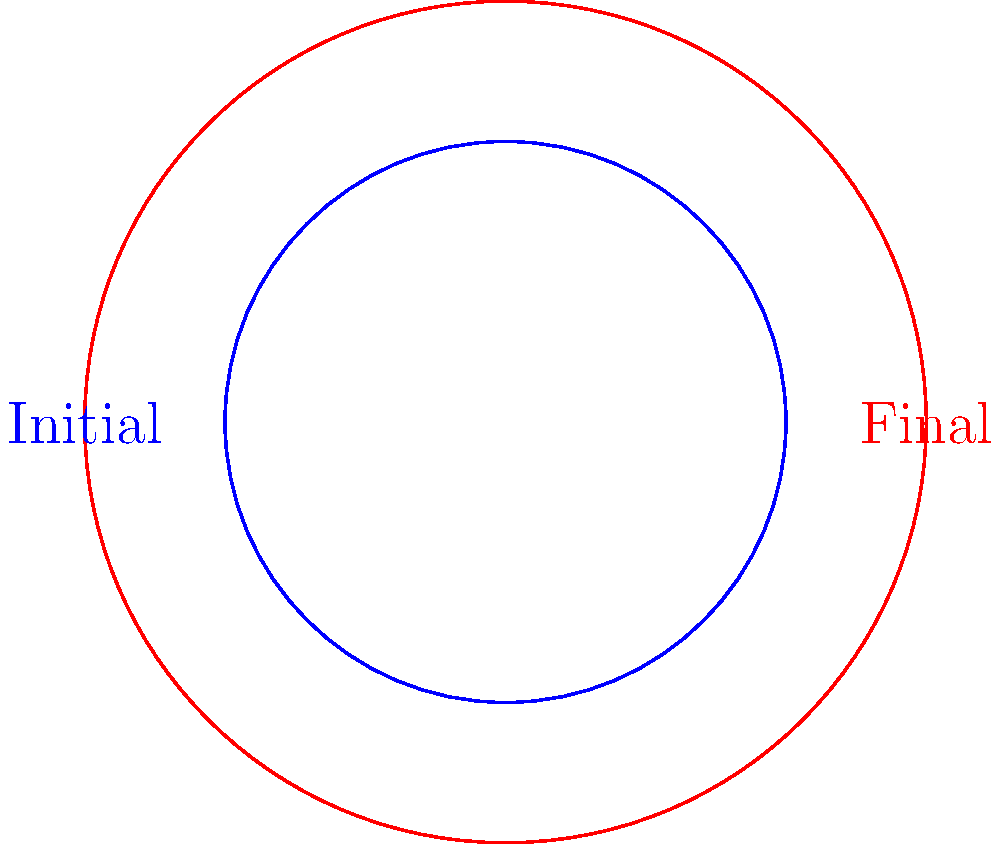As a general practitioner treating patients with addiction, you observe changes in pupil dilation during recovery. The initial pupil area is represented by a circle with radius 1 cm, and after treatment, it increases to a radius of 1.5 cm. Calculate the rate of change in pupil area relative to the change in radius. Express your answer in cm. To solve this problem, we'll follow these steps:

1) The area of a circle is given by the formula $A = \pi r^2$.

2) Let's calculate the initial and final areas:
   Initial area: $A_1 = \pi (1)^2 = \pi$ cm²
   Final area: $A_2 = \pi (1.5)^2 = 2.25\pi$ cm²

3) The change in area is:
   $\Delta A = A_2 - A_1 = 2.25\pi - \pi = 1.25\pi$ cm²

4) The change in radius is:
   $\Delta r = 1.5 - 1 = 0.5$ cm

5) The rate of change in area with respect to radius is given by:
   $$\frac{\Delta A}{\Delta r} = \frac{1.25\pi}{0.5} = 2.5\pi \approx 7.85$$ cm

This result indicates that for each centimeter increase in radius, the pupil area increases by approximately 7.85 square centimeters.
Answer: $2.5\pi$ cm 